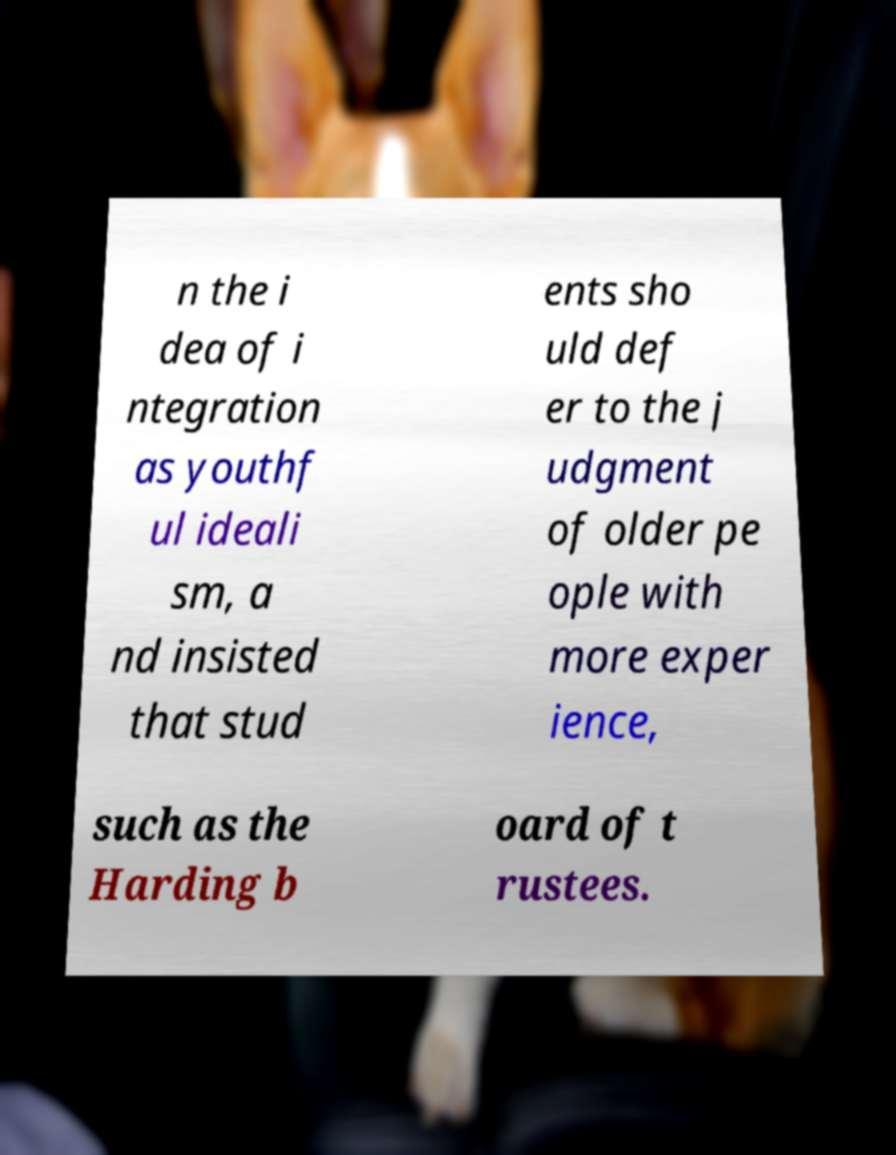Can you read and provide the text displayed in the image?This photo seems to have some interesting text. Can you extract and type it out for me? n the i dea of i ntegration as youthf ul ideali sm, a nd insisted that stud ents sho uld def er to the j udgment of older pe ople with more exper ience, such as the Harding b oard of t rustees. 